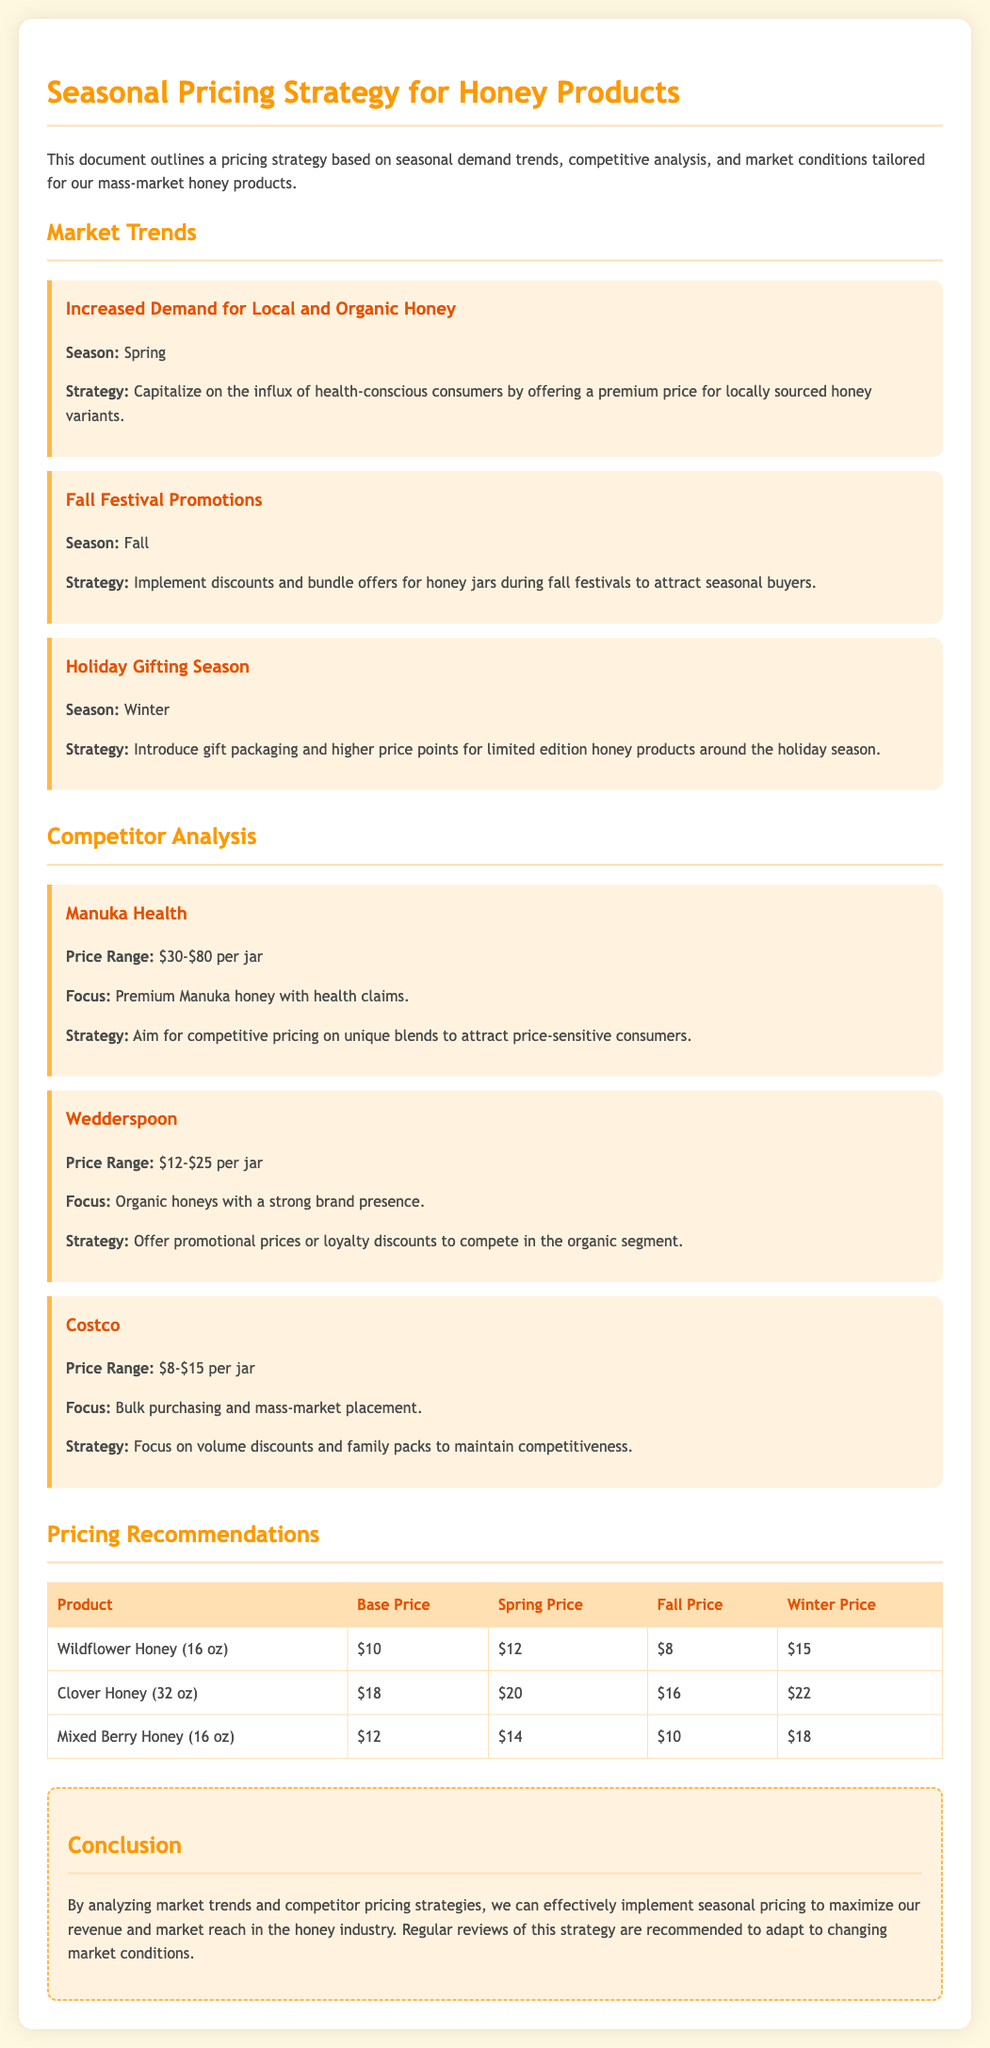What is the seasonal strategy for local honey? The strategy is to capitalize on the influx of health-conscious consumers by offering a premium price for locally sourced honey variants in the spring.
Answer: Premium price for locally sourced honey What is the price range for Manuka Health honey? The price range for Manuka Health honey is specified in the document as $30-$80 per jar.
Answer: $30-$80 per jar What promotional strategy is suggested for the fall season? The strategy suggested for the fall season is to implement discounts and bundle offers for honey jars during fall festivals.
Answer: Discounts and bundle offers What is the base price of Wildflower Honey (16 oz)? The base price of Wildflower Honey (16 oz) is listed in the document.
Answer: $10 What is the winter price for Mixed Berry Honey (16 oz)? The winter price is indicated in the pricing recommendations in the document.
Answer: $18 What is the focus of Costco's honey products? The document states that Costco's focus is on bulk purchasing and mass-market placement.
Answer: Bulk purchasing and mass-market placement What type of packaging should be introduced for the holiday season? The document recommends introducing gift packaging around the holiday season.
Answer: Gift packaging What is the strategy for competing with Wedderspoon? The strategy for competing with Wedderspoon is to offer promotional prices or loyalty discounts.
Answer: Promotional prices or loyalty discounts What is the conclusion regarding the pricing strategy? The conclusion summarizes that regular reviews of the strategy are recommended to adapt to changing market conditions.
Answer: Regular reviews are recommended 